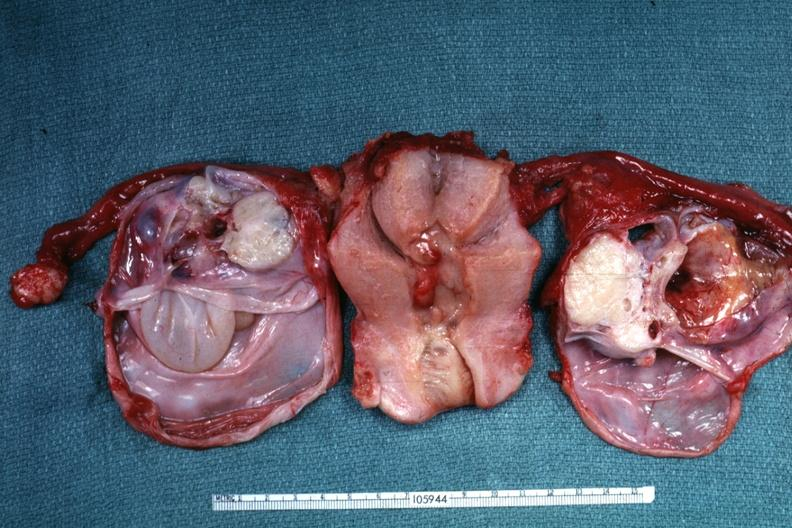where does this belong to?
Answer the question using a single word or phrase. Female reproductive system 